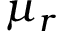<formula> <loc_0><loc_0><loc_500><loc_500>\mu _ { r }</formula> 